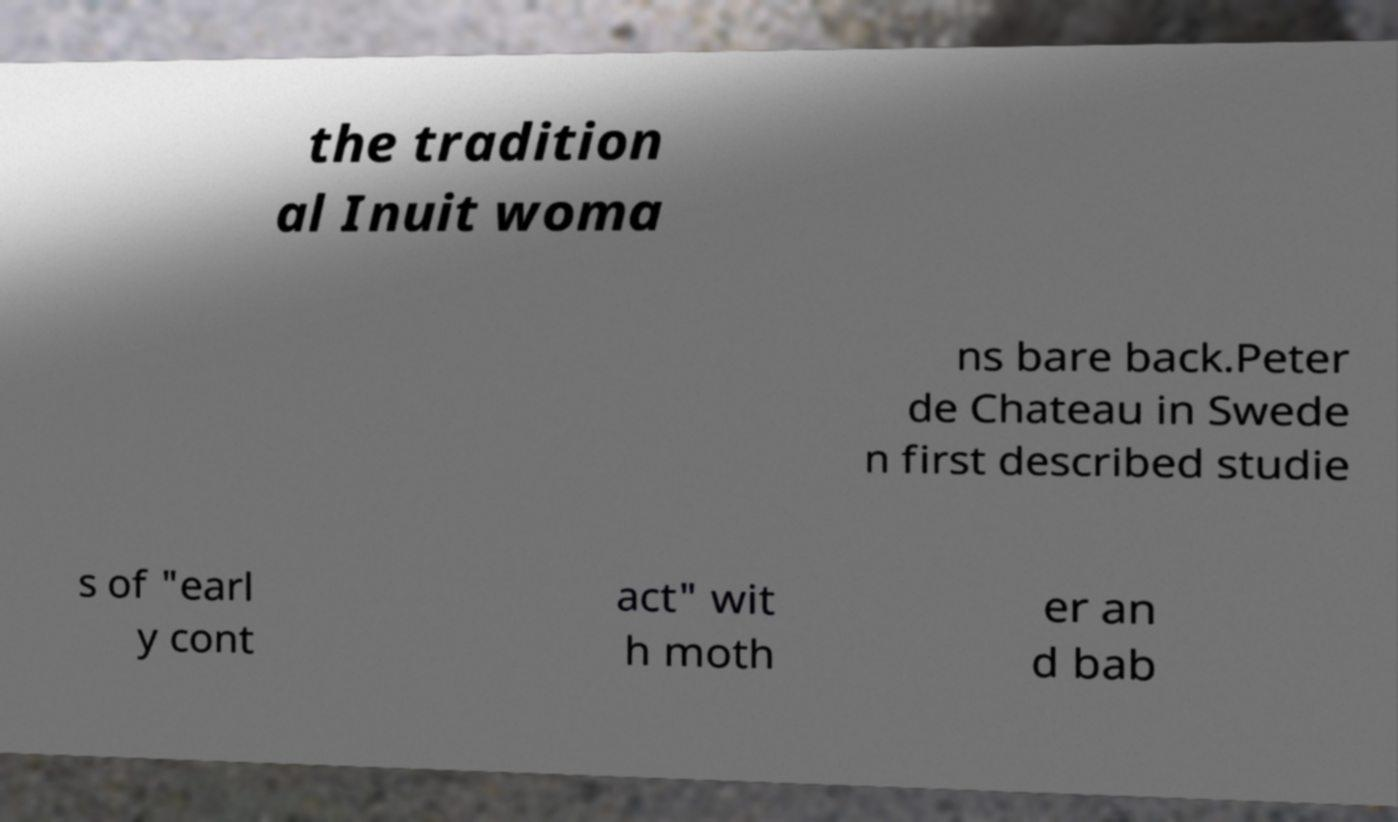I need the written content from this picture converted into text. Can you do that? the tradition al Inuit woma ns bare back.Peter de Chateau in Swede n first described studie s of "earl y cont act" wit h moth er an d bab 